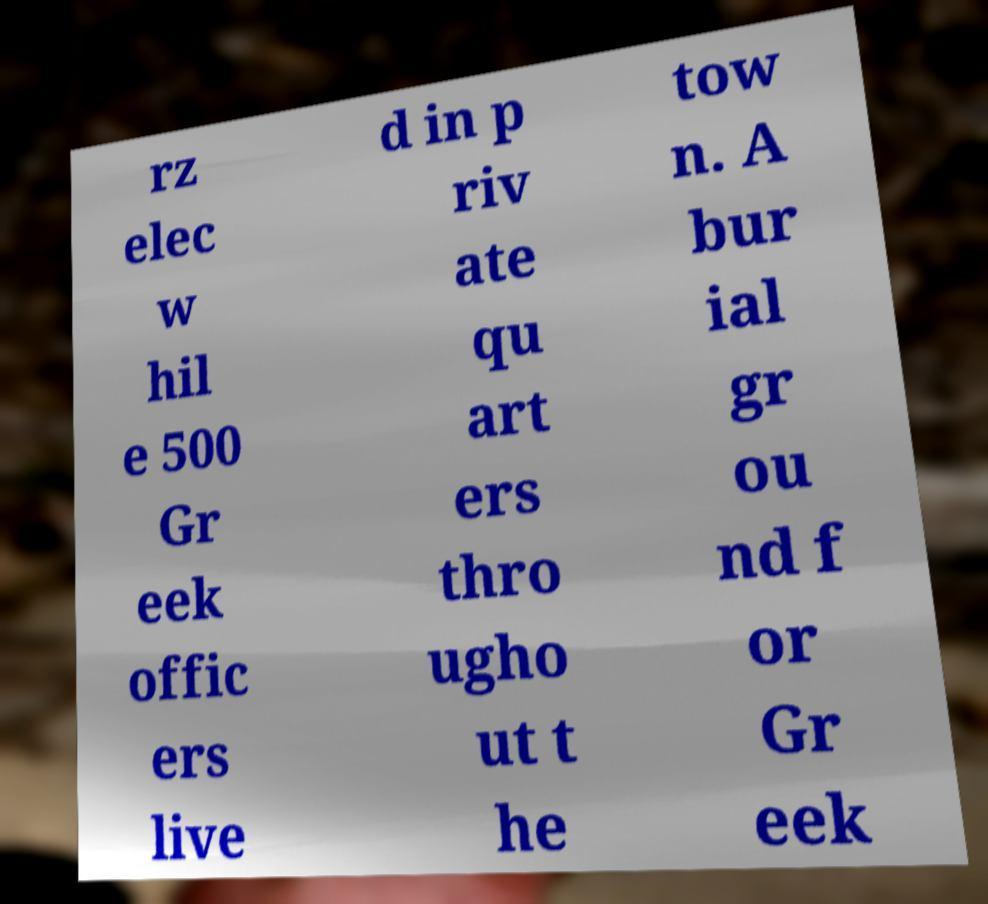Could you extract and type out the text from this image? rz elec w hil e 500 Gr eek offic ers live d in p riv ate qu art ers thro ugho ut t he tow n. A bur ial gr ou nd f or Gr eek 